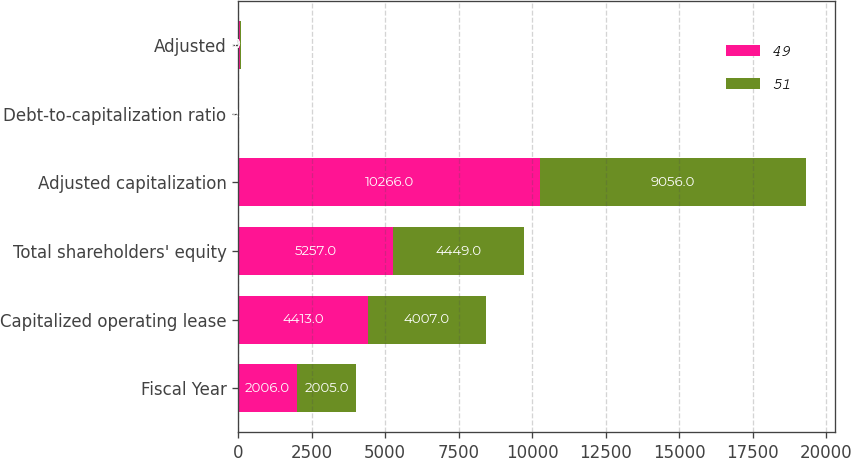Convert chart to OTSL. <chart><loc_0><loc_0><loc_500><loc_500><stacked_bar_chart><ecel><fcel>Fiscal Year<fcel>Capitalized operating lease<fcel>Total shareholders' equity<fcel>Adjusted capitalization<fcel>Debt-to-capitalization ratio<fcel>Adjusted<nl><fcel>49<fcel>2006<fcel>4413<fcel>5257<fcel>10266<fcel>10<fcel>49<nl><fcel>51<fcel>2005<fcel>4007<fcel>4449<fcel>9056<fcel>12<fcel>51<nl></chart> 